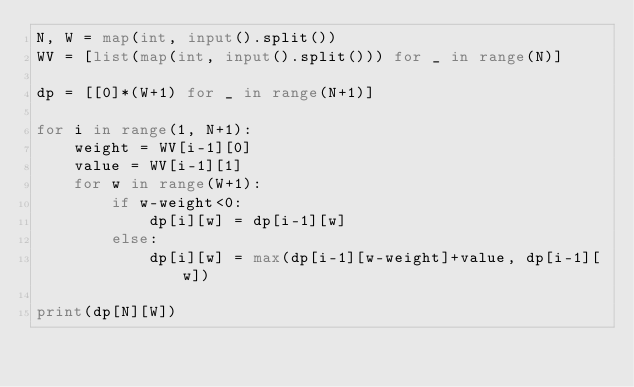Convert code to text. <code><loc_0><loc_0><loc_500><loc_500><_Python_>N, W = map(int, input().split())
WV = [list(map(int, input().split())) for _ in range(N)]

dp = [[0]*(W+1) for _ in range(N+1)]

for i in range(1, N+1):
    weight = WV[i-1][0]
    value = WV[i-1][1]
    for w in range(W+1):
        if w-weight<0:
            dp[i][w] = dp[i-1][w]
        else:
            dp[i][w] = max(dp[i-1][w-weight]+value, dp[i-1][w])

print(dp[N][W])</code> 